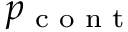Convert formula to latex. <formula><loc_0><loc_0><loc_500><loc_500>p _ { c o n t }</formula> 